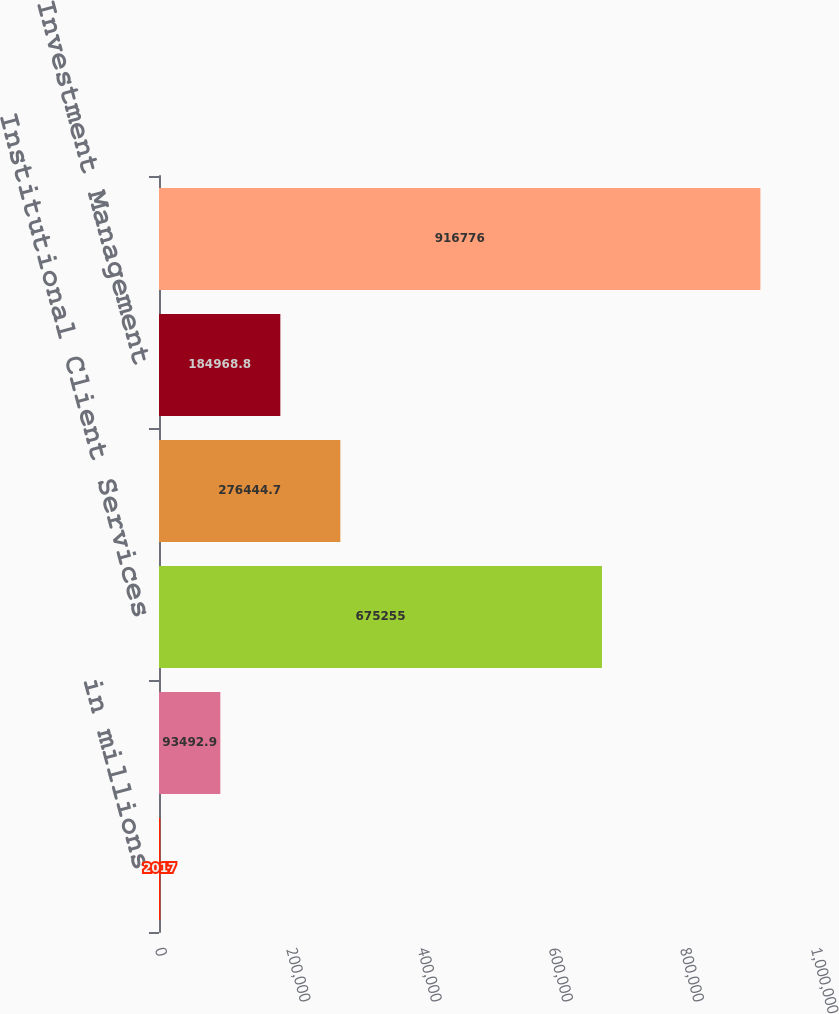Convert chart. <chart><loc_0><loc_0><loc_500><loc_500><bar_chart><fcel>in millions<fcel>Investment Banking<fcel>Institutional Client Services<fcel>Investing & Lending<fcel>Investment Management<fcel>Total assets<nl><fcel>2017<fcel>93492.9<fcel>675255<fcel>276445<fcel>184969<fcel>916776<nl></chart> 